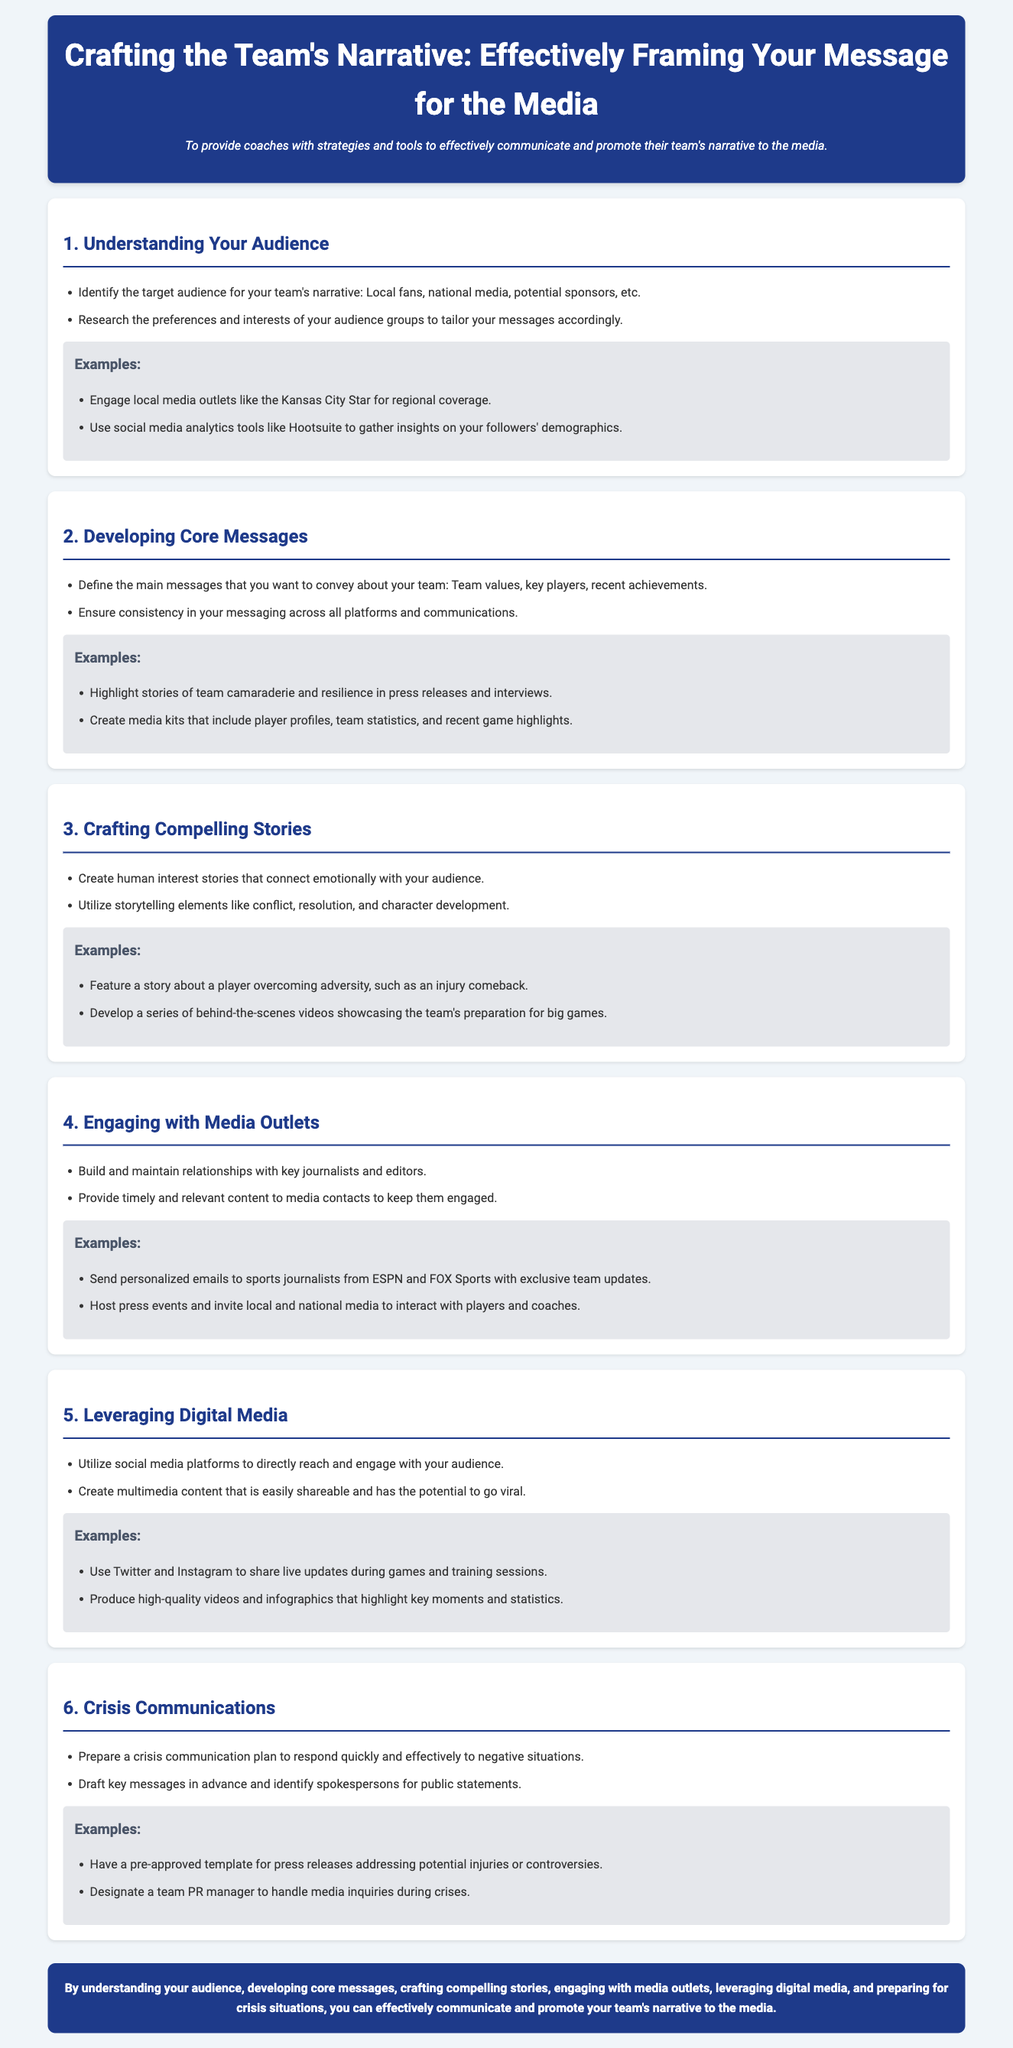What is the title of the lesson plan? The title of the lesson plan is found in the header section of the document, which states the main topic of the document.
Answer: Crafting the Team's Narrative: Effectively Framing Your Message for the Media What is the objective of the lesson plan? The objective is stated directly below the title, summarizing the main aim of the document.
Answer: To provide coaches with strategies and tools to effectively communicate and promote their team's narrative to the media How many sections are included in the lesson plan? The document has numbered sections that describe different focuses; counting these gives the total number.
Answer: 6 What is a key strategy for understanding your audience? A specific strategy mentioned under the 'Understanding Your Audience' section describes a method for identifying who the audience is.
Answer: Identify the target audience for your team's narrative What should coaches prepare for crisis situations? The 'Crisis Communications' section indicates an important element that coaches need to have ready before facing negative situations.
Answer: A crisis communication plan What type of content is suggested to engage with media outlets? The document includes recommendations for keeping media contacts engaged through certain types of communication methods.
Answer: Timely and relevant content How should coaches leverage digital media? This is an instruction given in the 'Leveraging Digital Media' section regarding how to interact with audiences.
Answer: Utilize social media platforms Which example is provided for crisis communication? An example is given in the 'Crisis Communications' section pertaining to a standard practice during negative events.
Answer: Have a pre-approved template for press releases addressing potential injuries or controversies 